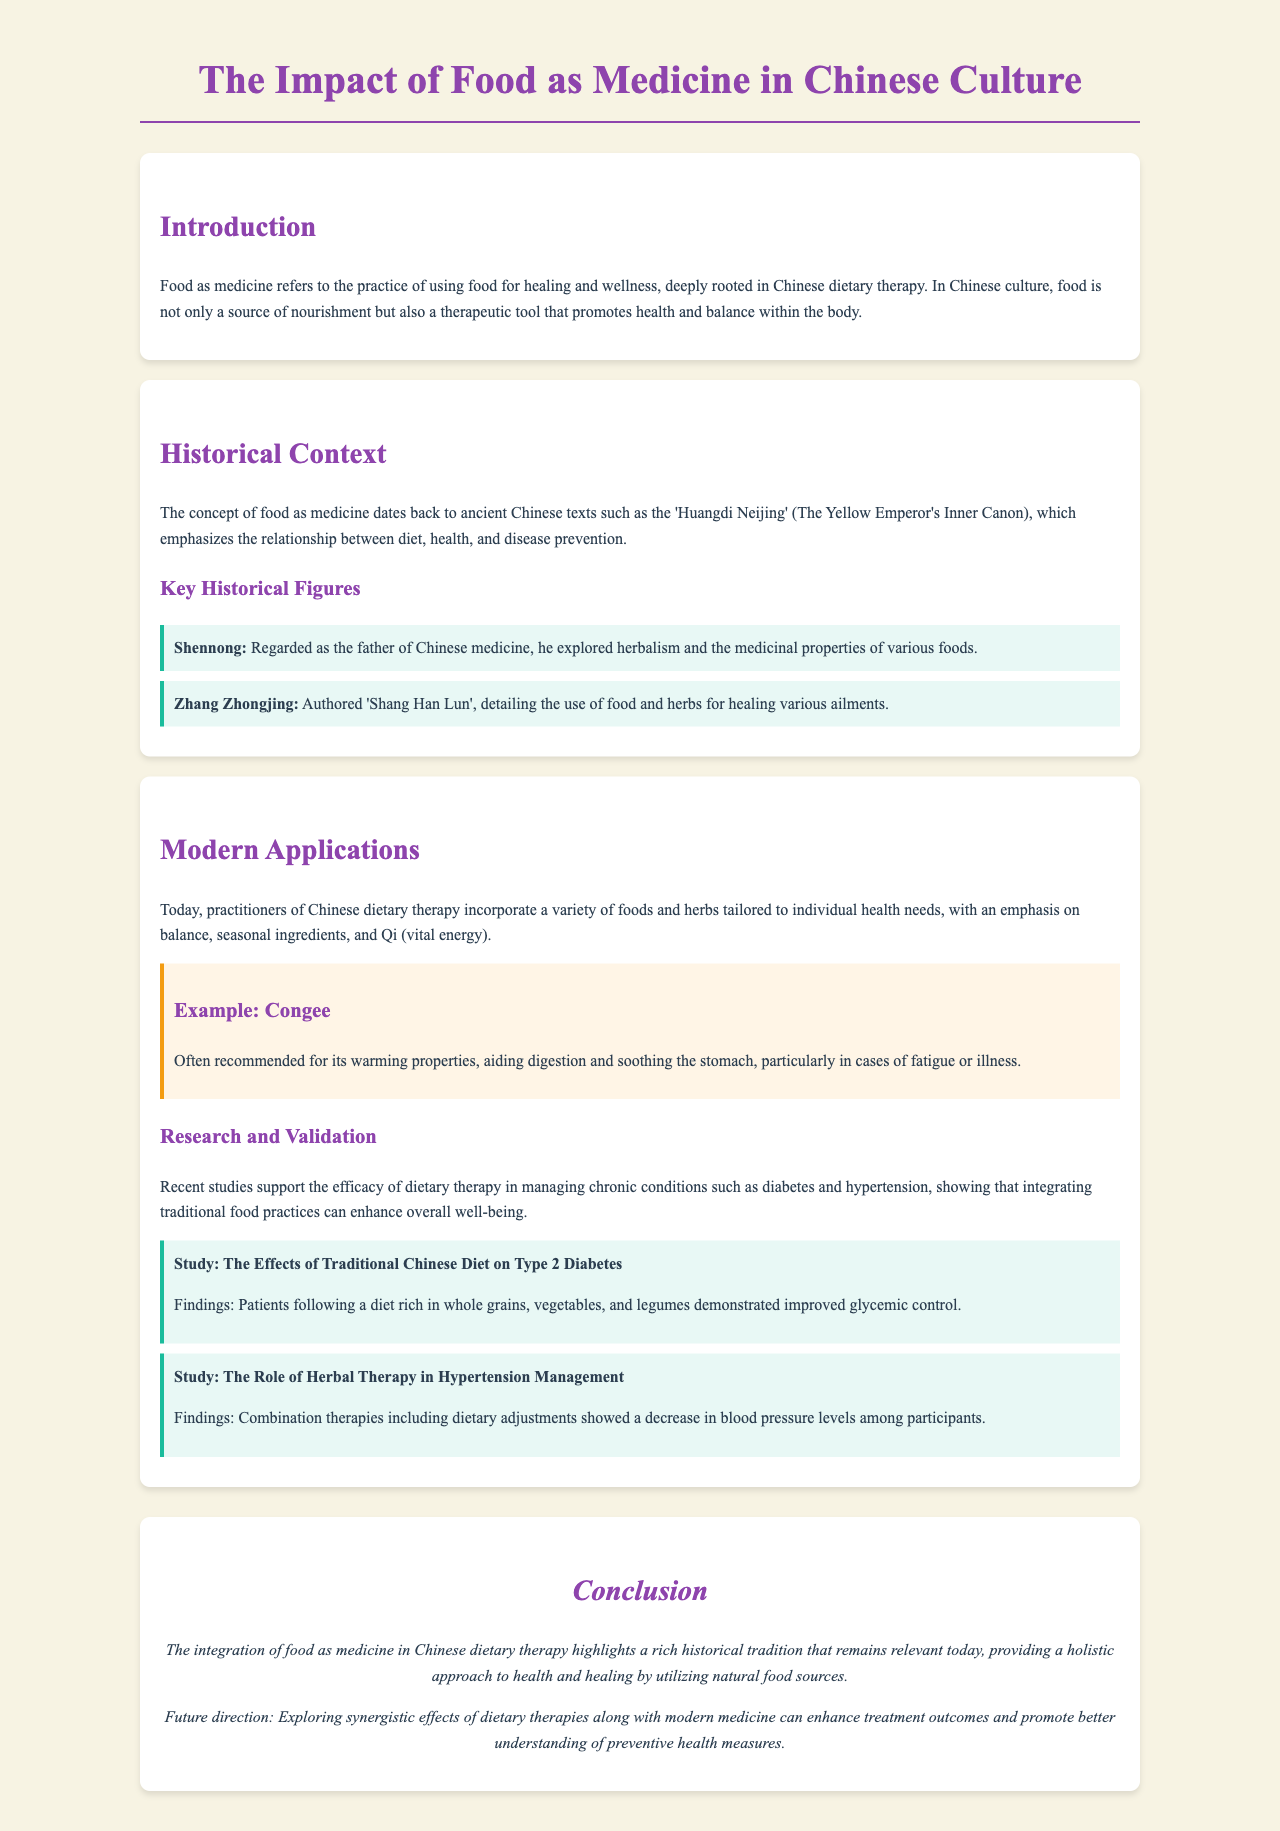What is the title of the document? The title is found in the header of the document and summarizes the main topic addressed in it.
Answer: The Impact of Food as Medicine in Chinese Culture Who is regarded as the father of Chinese medicine? This information is provided in the section discussing key historical figures in the context of dietary therapy.
Answer: Shennong What ancient text emphasizes the relationship between diet, health, and disease prevention? The text is mentioned in the historical context section and is significant in Chinese medical literature.
Answer: Huangdi Neijing What is congee often recommended for? The document discusses specific applications of foods in modern dietary therapy, including their purposes.
Answer: Warming properties What is one key finding related to Type 2 Diabetes in the studies mentioned? This finding is part of research presented under modern applications of food as medicine and highlights a specific food practice.
Answer: Improved glycemic control What is the future direction mentioned in the conclusion? This aspect of the conclusion explores next steps for research and application in dietary therapy intertwined with modern medicine.
Answer: Exploring synergistic effects How is food viewed in Chinese culture according to the introduction? This perspective is outlined in the opening section and characterizes the essential role of food beyond just nutrition.
Answer: Therapeutic tool What color is used in the headings throughout the document? The chosen color for these elements signifies importance and coherence in the visual design of the document.
Answer: Purple 